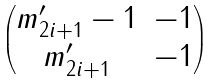Convert formula to latex. <formula><loc_0><loc_0><loc_500><loc_500>\begin{pmatrix} m ^ { \prime } _ { 2 i + 1 } - 1 & - 1 \\ m ^ { \prime } _ { 2 i + 1 } & - 1 \end{pmatrix}</formula> 